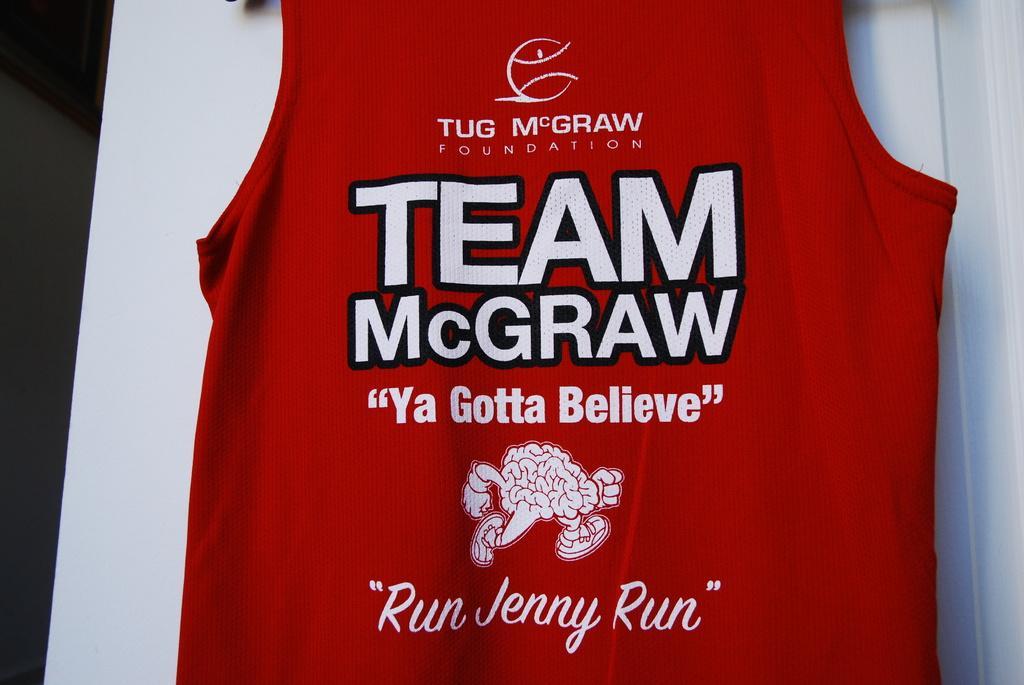In one or two sentences, can you explain what this image depicts? In this image printed red T-shirt on a table. 